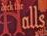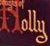Read the text from these images in sequence, separated by a semicolon. Halls; Holly 